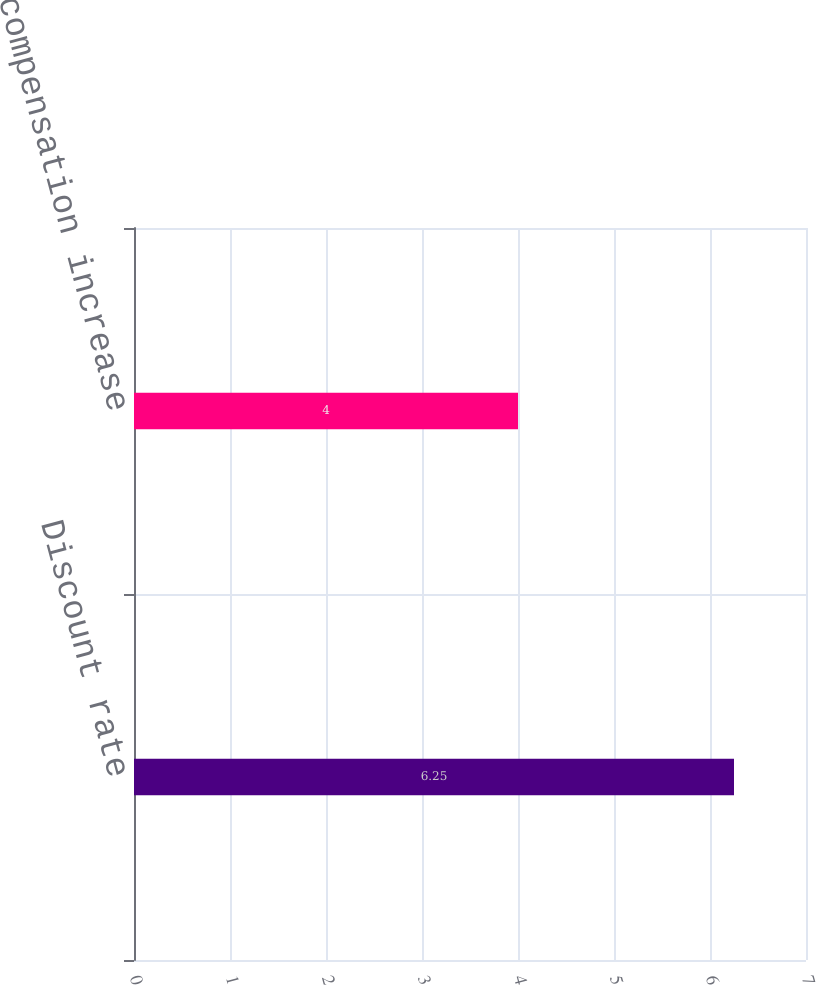Convert chart to OTSL. <chart><loc_0><loc_0><loc_500><loc_500><bar_chart><fcel>Discount rate<fcel>Rate of compensation increase<nl><fcel>6.25<fcel>4<nl></chart> 